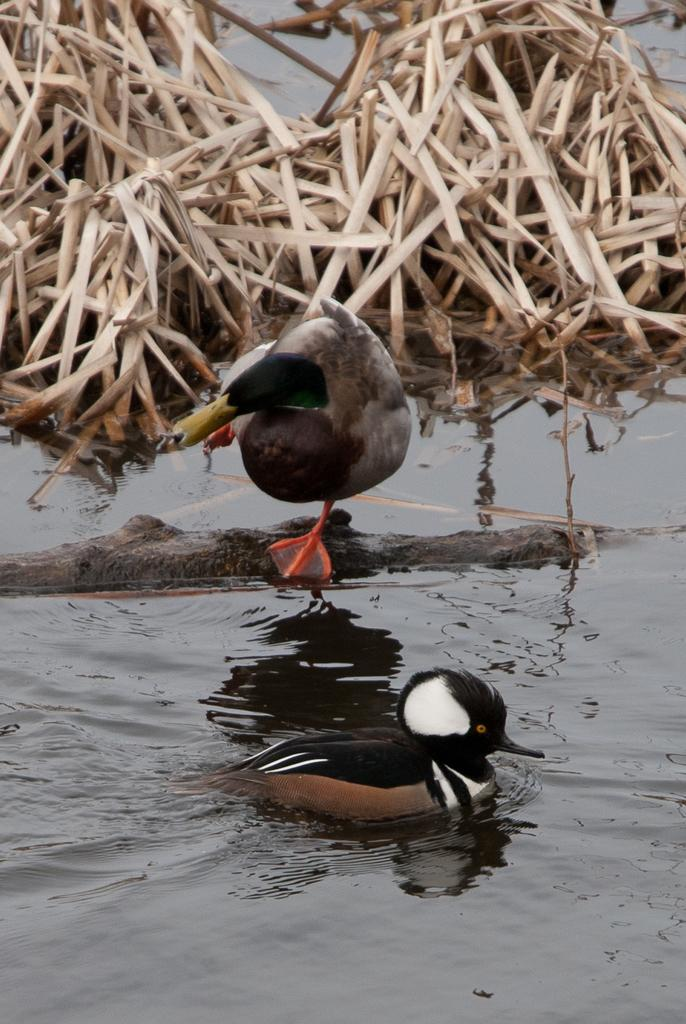What is there are any living creatures in the image? Yes, there are birds in the center of the image. What is located at the bottom of the image? There is water at the bottom of the image. What type of vegetation can be seen in the background of the image? Dry grass is present in the background of the image. How many cherries are hanging from the net in the image? There is no net or cherries present in the image. What type of range can be seen in the background of the image? There is no range present in the image; it features birds, water, and dry grass. 